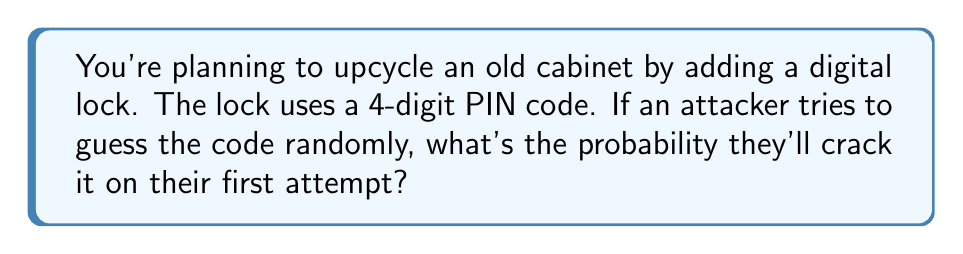Could you help me with this problem? Let's approach this step-by-step:

1) First, we need to determine the total number of possible 4-digit PINs. 
   - Each digit can be any number from 0 to 9.
   - For each position, we have 10 choices.
   - Total number of possibilities = $10 \times 10 \times 10 \times 10 = 10^4 = 10,000$

2) The probability of guessing the correct PIN on the first try is:
   $$P(\text{correct guess}) = \frac{\text{number of favorable outcomes}}{\text{total number of possible outcomes}}$$

3) In this case:
   - There's only one correct PIN (favorable outcome)
   - There are 10,000 possible PINs (total outcomes)

4) Therefore, the probability is:
   $$P(\text{correct guess}) = \frac{1}{10,000} = 0.0001 = 0.01\%$$

This extremely low probability demonstrates why even a simple 4-digit PIN can be effective against random guessing attacks, making it a decent choice for your upcycled cabinet's security.
Answer: $\frac{1}{10,000}$ or $0.0001$ or $0.01\%$ 